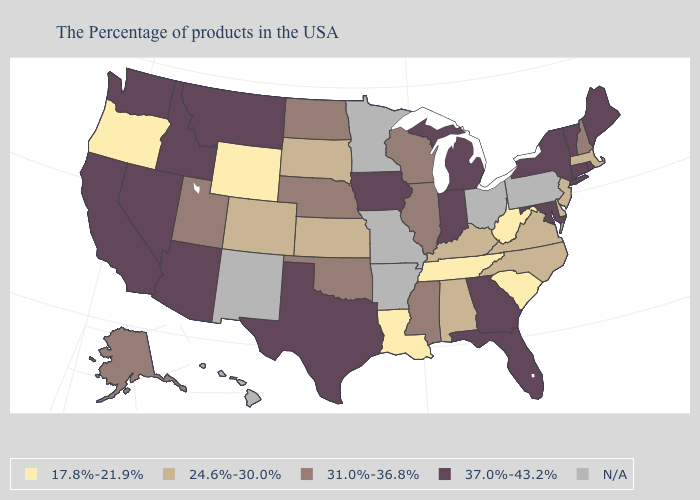Name the states that have a value in the range N/A?
Answer briefly. Pennsylvania, Ohio, Missouri, Arkansas, Minnesota, New Mexico, Hawaii. Which states have the lowest value in the USA?
Short answer required. South Carolina, West Virginia, Tennessee, Louisiana, Wyoming, Oregon. Does Oregon have the lowest value in the USA?
Answer briefly. Yes. What is the value of Michigan?
Be succinct. 37.0%-43.2%. Name the states that have a value in the range 31.0%-36.8%?
Concise answer only. New Hampshire, Wisconsin, Illinois, Mississippi, Nebraska, Oklahoma, North Dakota, Utah, Alaska. Name the states that have a value in the range N/A?
Keep it brief. Pennsylvania, Ohio, Missouri, Arkansas, Minnesota, New Mexico, Hawaii. What is the value of Oregon?
Keep it brief. 17.8%-21.9%. What is the value of Hawaii?
Quick response, please. N/A. What is the lowest value in the USA?
Be succinct. 17.8%-21.9%. Name the states that have a value in the range N/A?
Concise answer only. Pennsylvania, Ohio, Missouri, Arkansas, Minnesota, New Mexico, Hawaii. What is the highest value in states that border Oklahoma?
Quick response, please. 37.0%-43.2%. 